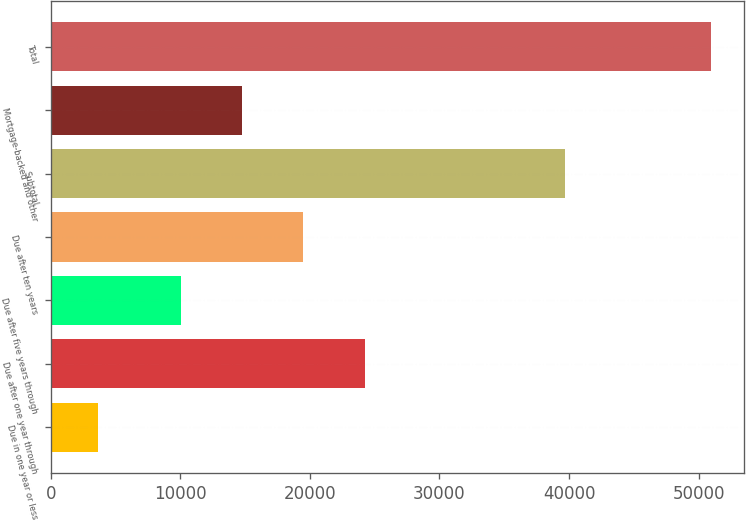Convert chart to OTSL. <chart><loc_0><loc_0><loc_500><loc_500><bar_chart><fcel>Due in one year or less<fcel>Due after one year through<fcel>Due after five years through<fcel>Due after ten years<fcel>Subtotal<fcel>Mortgage-backed and other<fcel>Total<nl><fcel>3619<fcel>24219.3<fcel>10023.2<fcel>19487.3<fcel>39656.8<fcel>14755.2<fcel>50939.3<nl></chart> 